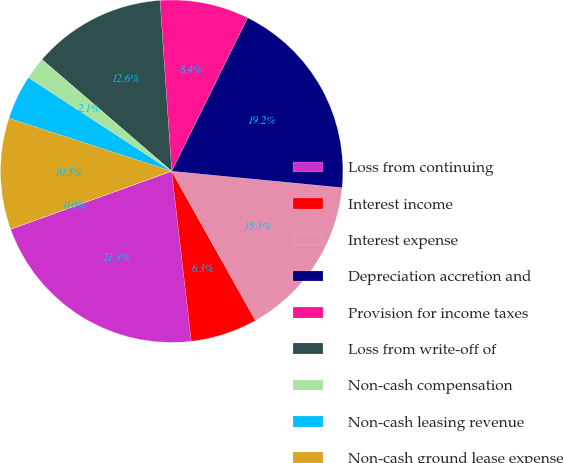Convert chart to OTSL. <chart><loc_0><loc_0><loc_500><loc_500><pie_chart><fcel>Loss from continuing<fcel>Interest income<fcel>Interest expense<fcel>Depreciation accretion and<fcel>Provision for income taxes<fcel>Loss from write-off of<fcel>Non-cash compensation<fcel>Non-cash leasing revenue<fcel>Non-cash ground lease expense<fcel>Other expense (income)<nl><fcel>21.32%<fcel>6.31%<fcel>15.33%<fcel>19.22%<fcel>8.4%<fcel>12.6%<fcel>2.11%<fcel>4.21%<fcel>10.5%<fcel>0.01%<nl></chart> 